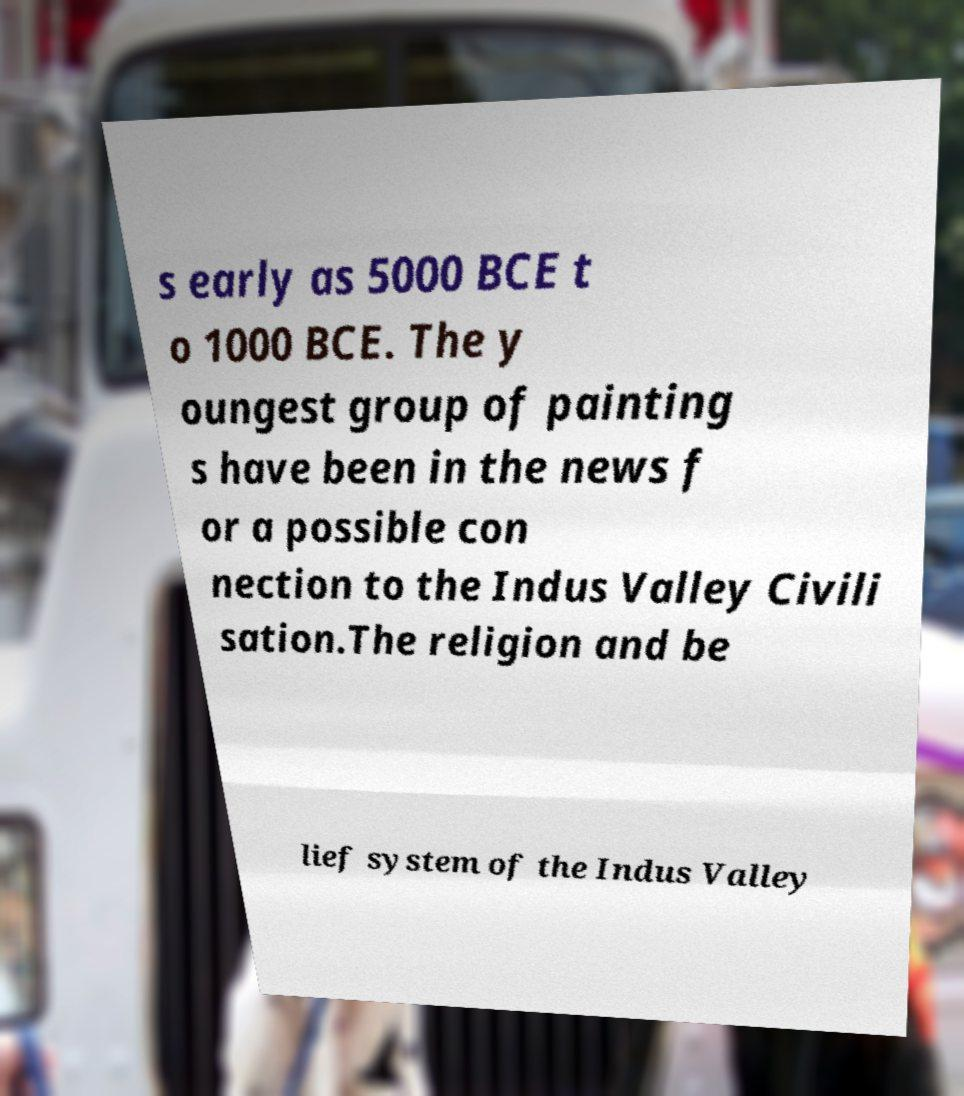I need the written content from this picture converted into text. Can you do that? s early as 5000 BCE t o 1000 BCE. The y oungest group of painting s have been in the news f or a possible con nection to the Indus Valley Civili sation.The religion and be lief system of the Indus Valley 